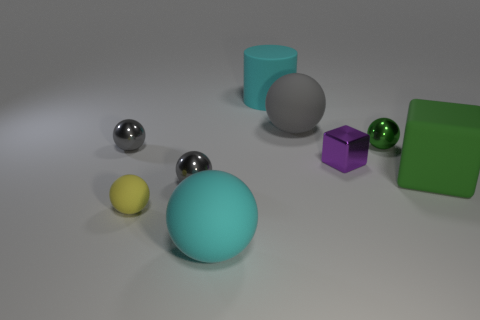Does the cyan sphere have the same size as the metal ball that is to the right of the cylinder?
Ensure brevity in your answer.  No. What color is the object that is in front of the green sphere and right of the tiny block?
Ensure brevity in your answer.  Green. What number of objects are large cyan things that are behind the purple thing or big cyan rubber objects behind the green sphere?
Provide a short and direct response. 1. There is a large matte object to the left of the large cyan rubber thing that is on the right side of the cyan thing in front of the purple metallic block; what is its color?
Provide a succinct answer. Cyan. Is there a tiny metallic object of the same shape as the gray matte object?
Provide a succinct answer. Yes. What number of large yellow matte spheres are there?
Offer a terse response. 0. The yellow thing is what shape?
Your answer should be compact. Sphere. How many cyan balls have the same size as the green matte block?
Provide a succinct answer. 1. Do the large gray rubber object and the small green metal object have the same shape?
Offer a terse response. Yes. The tiny sphere right of the metallic thing that is in front of the rubber block is what color?
Your answer should be very brief. Green. 